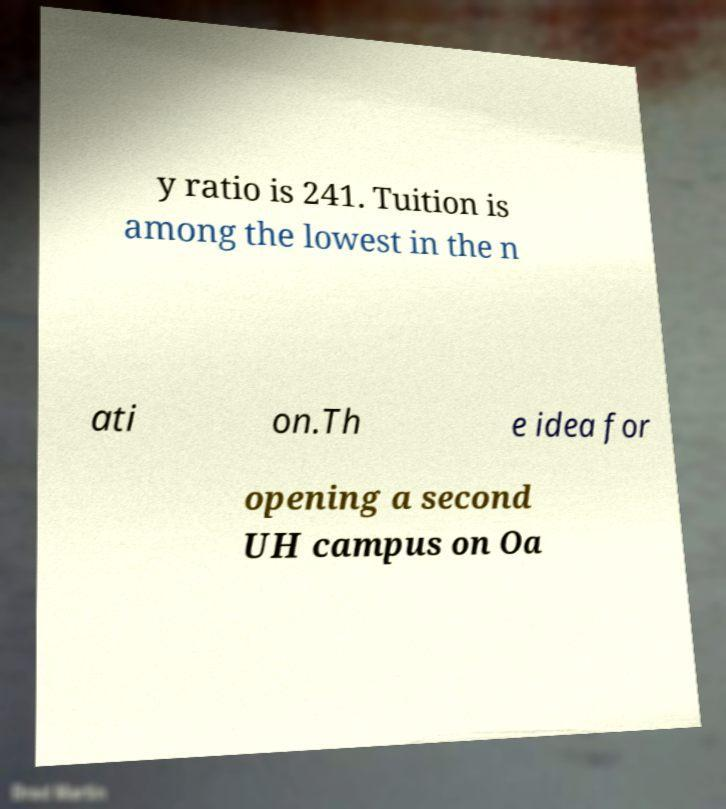Please read and relay the text visible in this image. What does it say? y ratio is 241. Tuition is among the lowest in the n ati on.Th e idea for opening a second UH campus on Oa 